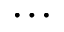<formula> <loc_0><loc_0><loc_500><loc_500>\dots</formula> 